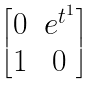Convert formula to latex. <formula><loc_0><loc_0><loc_500><loc_500>\begin{bmatrix} 0 & e ^ { t ^ { 1 } } \\ 1 & 0 \end{bmatrix}</formula> 